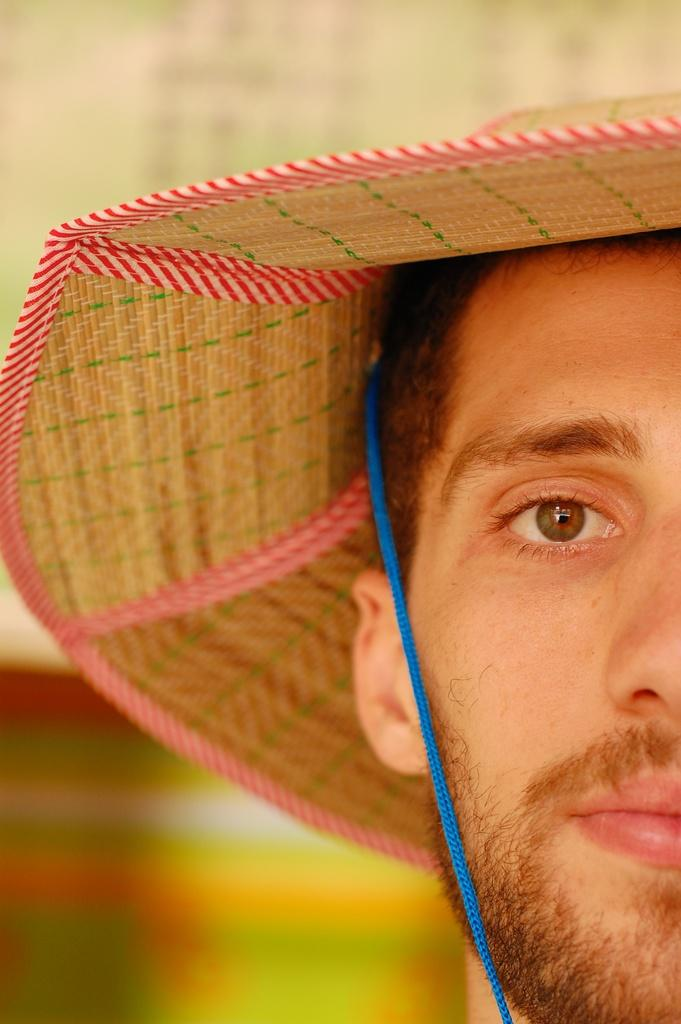Who or what is the main subject in the image? There is a person in the image. What is the person wearing on their head? The person is wearing a hat. Can you describe any specific details about the hat? The hat has a blue string attached to it. How many boundaries are visible in the image? There is no mention of boundaries in the image, so it is not possible to determine how many there are. 